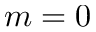<formula> <loc_0><loc_0><loc_500><loc_500>m = 0</formula> 